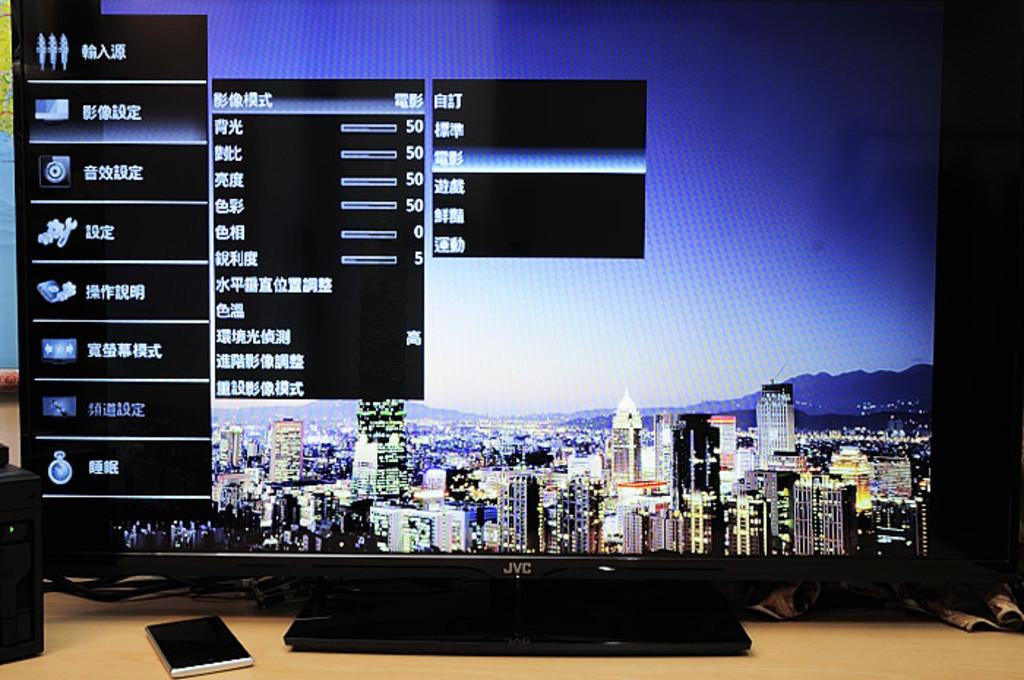<image>
Provide a brief description of the given image. A JVC monitor with a cityscape background sits on a table. 